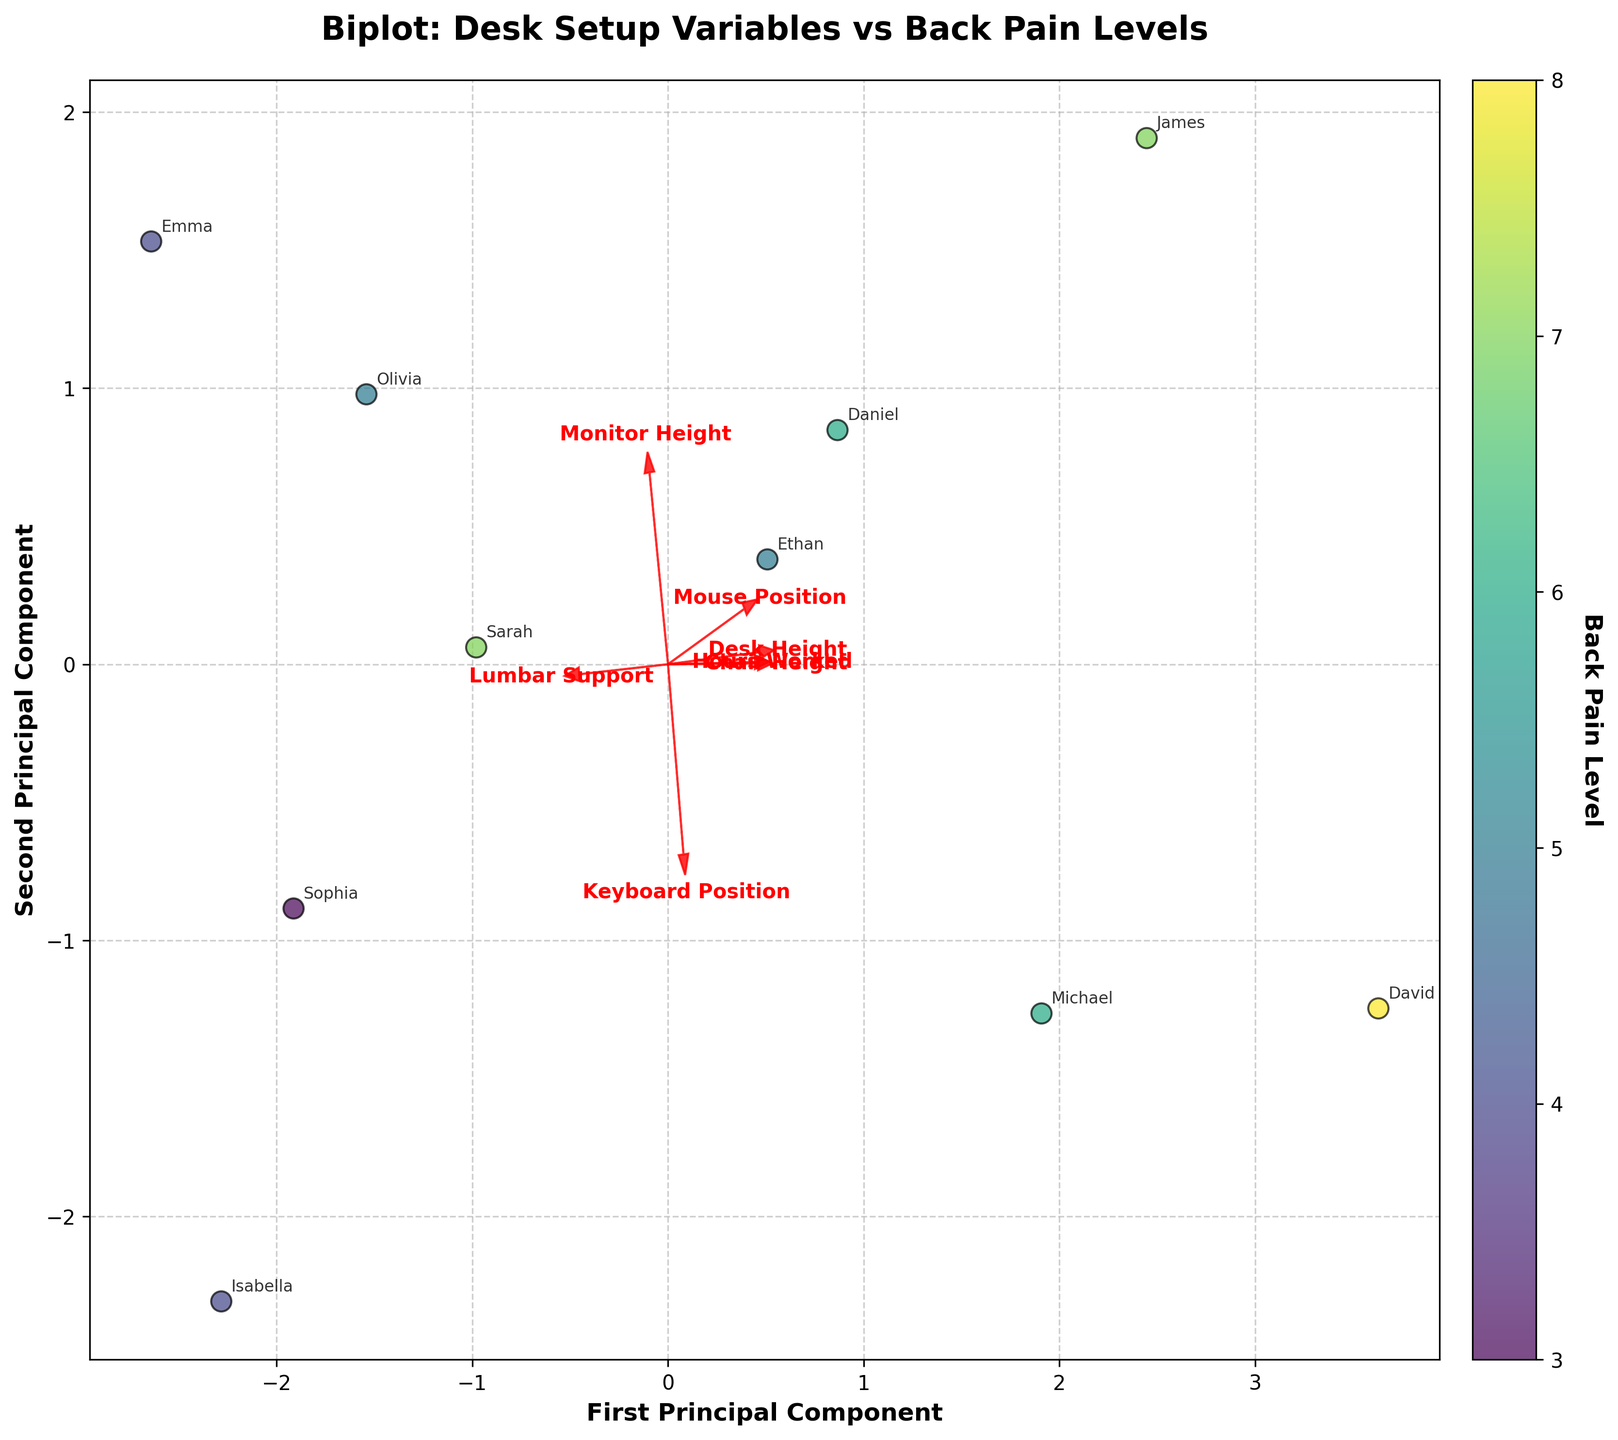What's the title of the plot? The title of the plot is typically located at the top and describes the main subject of the visualization. Here, it indicates what the biplot is about based on the dataset provided.
Answer: Biplot: Desk Setup Variables vs Back Pain Levels How many arrow vectors are displayed for the desk setup variables? To determine the number of arrow vectors, one needs to count each arrow representing a different desk setup variable on the plot.
Answer: 7 Which principal component axis appears to explain more variance in the data? The principal component axis that is more stretched out and has the arrow endpoints further spread from the origin explains more variance in the data. The labels 'First Principal Component' and 'Second Principal Component' on the axes provide further guidance.
Answer: The First Principal Component Which desk setup variable has the highest positive influence on the first principal component? To determine this, observe the direction and length of the arrows. The arrow pointing farthest in the positive direction along the first principal component axis indicates the strongest positive influence.
Answer: Hours Worked Which variables are most closely associated with higher back pain levels based on the plot? Higher back pain levels are indicated by darker data points on the plot. The desk setup variables with arrow vectors pointing in the same direction as these darker points are most closely associated with higher back pain levels.
Answer: Chair Height and Hours Worked Do 'Monitor Height' and 'Desk Height' have similar influences in the data? Comparing the arrow directions and lengths for 'Monitor Height' and 'Desk Height', if they point in similar directions and have similar lengths, their influence on the data is similar in the principal component space.
Answer: Yes For Sarah and David, who worked more hours per week? Identify the data points labeled 'Sarah' and 'David', and observe their positions related to the Hours Worked arrow. The point further along the direction of the Hours Worked vector indicates more hours worked.
Answer: David Are 'Lumbar Support' and 'Keyboard Position' positively correlated? Look at the directions of the arrows for 'Lumbar Support' and 'Keyboard Position'. If they point in similar directions, they are positively correlated.
Answer: Yes What can you infer about 'Mouse Position' and its relationship to back pain levels? Examine the direction of the 'Mouse Position' arrow relative to the spread of different back pain levels on the plot. Assess if higher back pain levels are clustered around the direction of the 'Mouse Position' arrow.
Answer: Weak or no clear association 